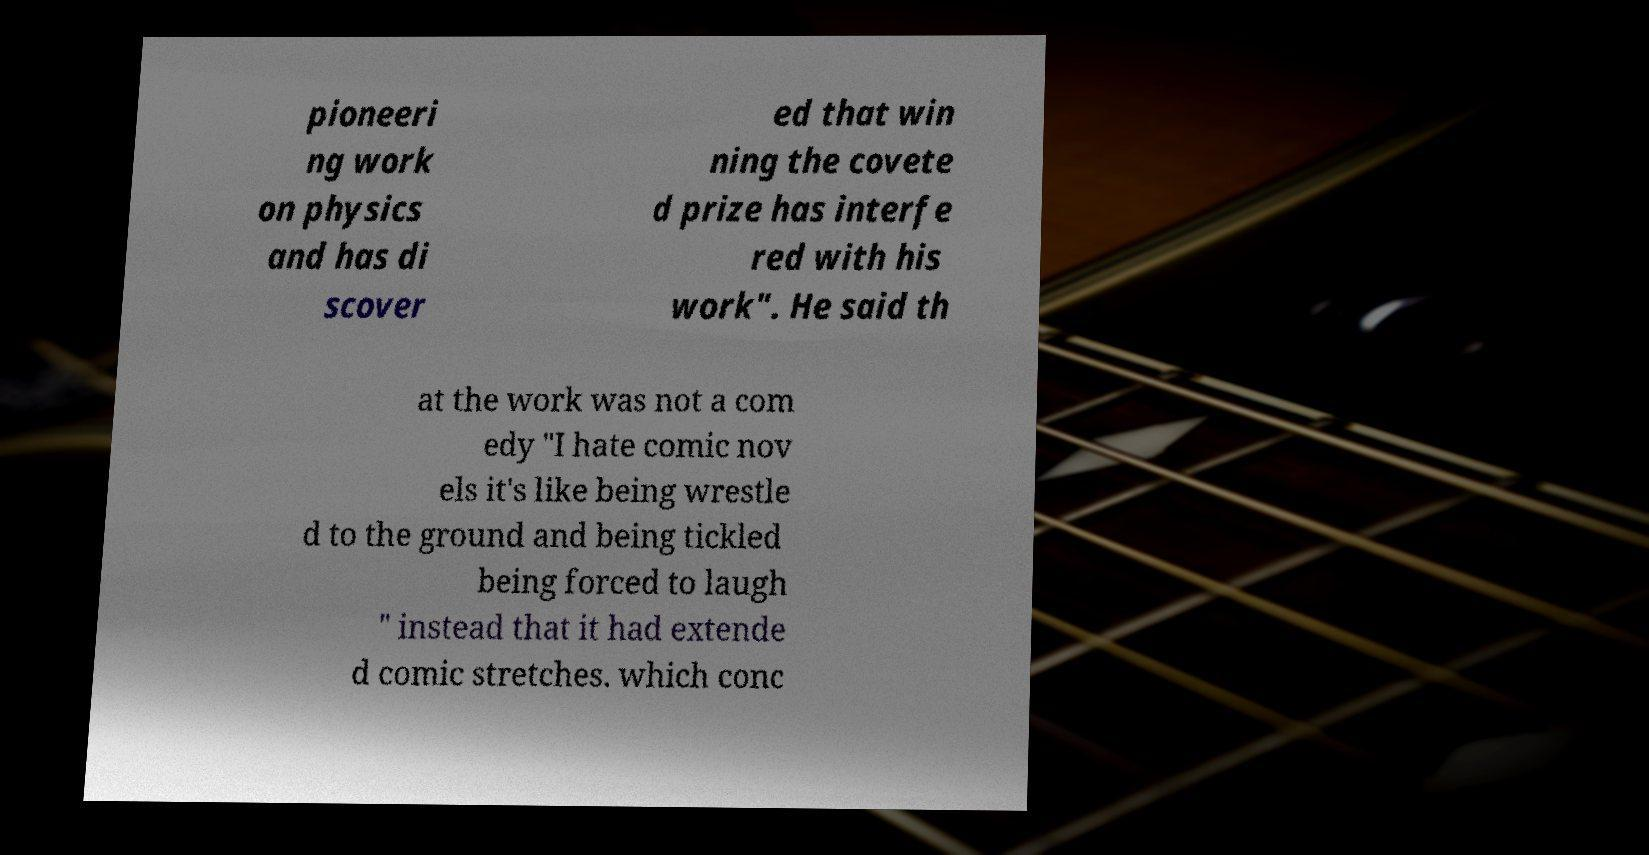Can you accurately transcribe the text from the provided image for me? pioneeri ng work on physics and has di scover ed that win ning the covete d prize has interfe red with his work". He said th at the work was not a com edy "I hate comic nov els it's like being wrestle d to the ground and being tickled being forced to laugh " instead that it had extende d comic stretches. which conc 